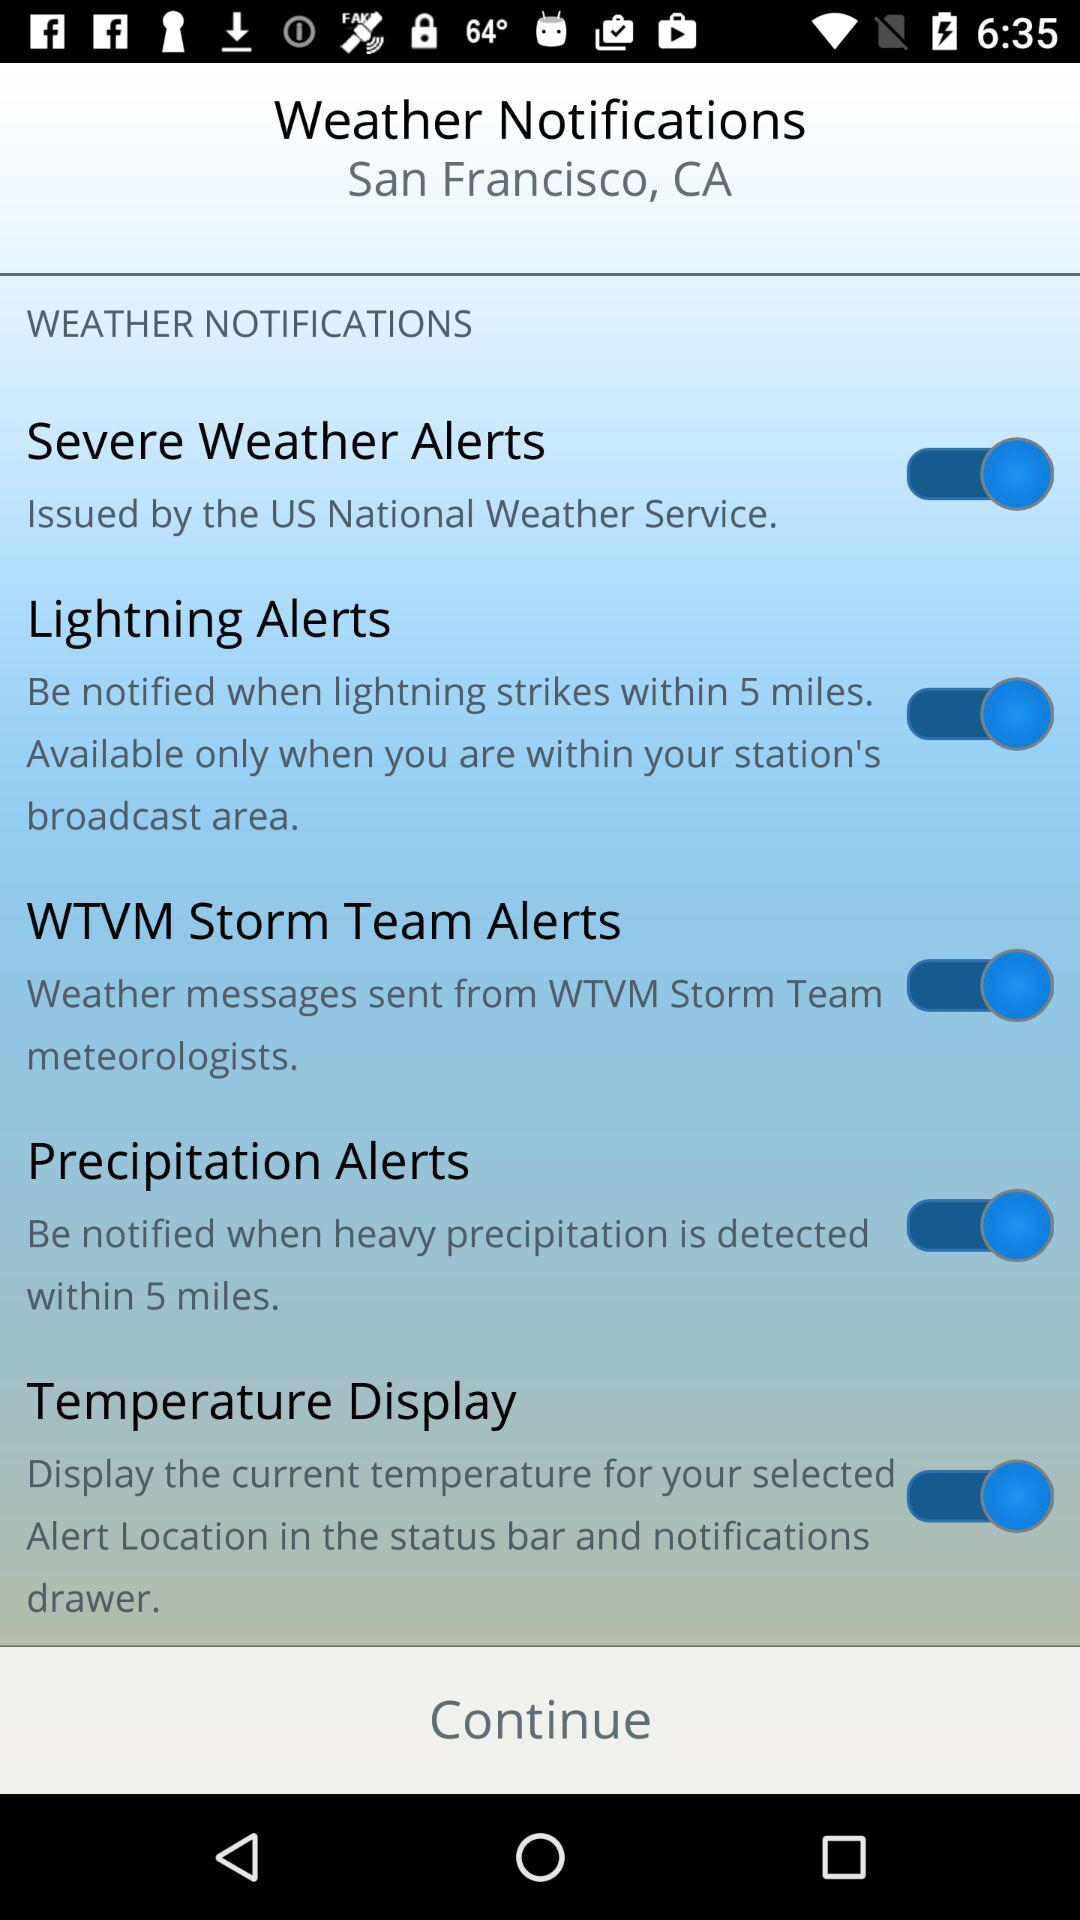How many alert types are available?
Answer the question using a single word or phrase. 4 